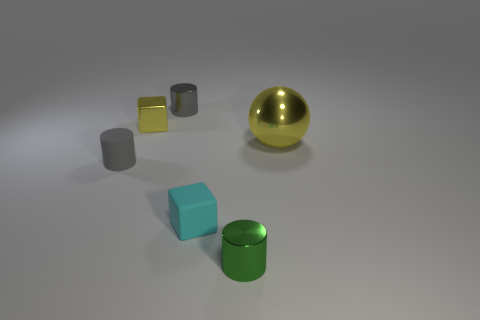Is the tiny green object made of the same material as the small cube on the left side of the cyan block?
Your answer should be very brief. Yes. Is the number of cylinders that are behind the rubber cube greater than the number of cyan rubber things?
Provide a succinct answer. Yes. There is a small shiny object that is the same color as the rubber cylinder; what is its shape?
Provide a succinct answer. Cylinder. Is there a tiny yellow thing made of the same material as the green object?
Provide a short and direct response. Yes. Do the gray thing that is right of the tiny yellow metallic cube and the yellow object that is in front of the tiny yellow thing have the same material?
Your answer should be very brief. Yes. Is the number of tiny matte blocks to the right of the big yellow sphere the same as the number of small gray matte cylinders that are right of the small green metallic object?
Offer a very short reply. Yes. The rubber cube that is the same size as the green thing is what color?
Your answer should be very brief. Cyan. Is there a tiny shiny object that has the same color as the big metallic thing?
Keep it short and to the point. Yes. How many things are small cubes that are in front of the small matte cylinder or tiny matte cylinders?
Provide a short and direct response. 2. How many other objects are there of the same size as the green thing?
Offer a very short reply. 4. 